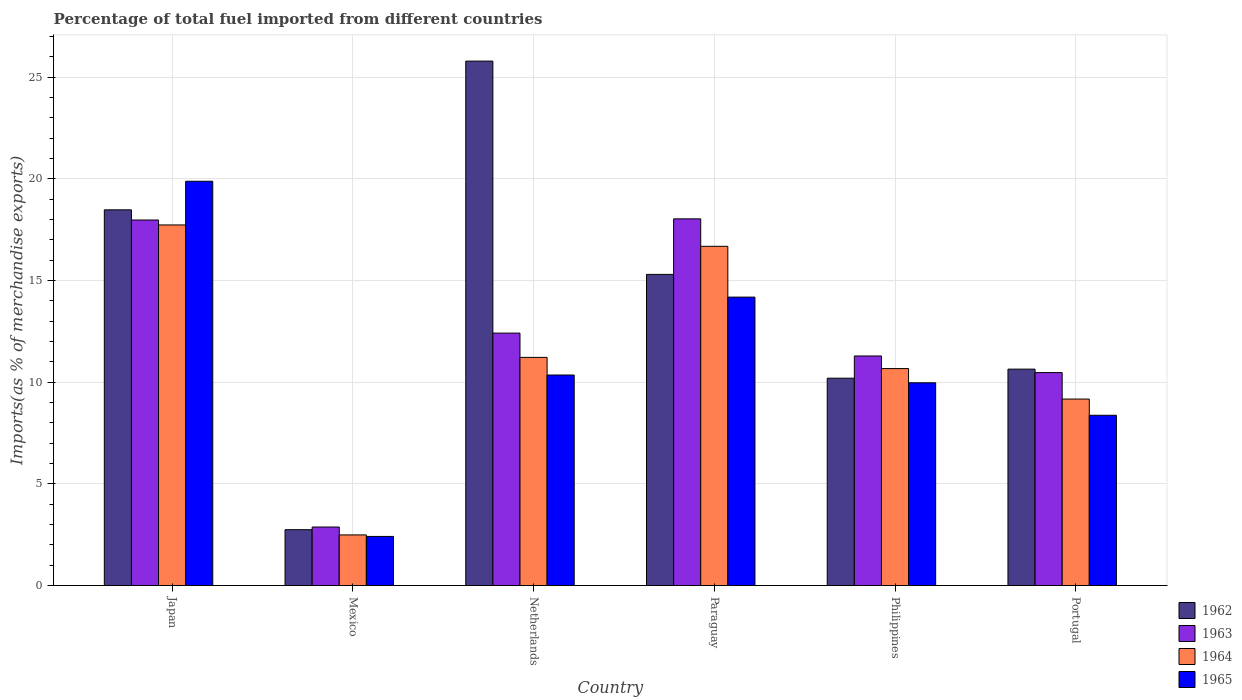How many groups of bars are there?
Your response must be concise. 6. Are the number of bars on each tick of the X-axis equal?
Give a very brief answer. Yes. What is the label of the 4th group of bars from the left?
Your answer should be very brief. Paraguay. In how many cases, is the number of bars for a given country not equal to the number of legend labels?
Provide a short and direct response. 0. What is the percentage of imports to different countries in 1963 in Japan?
Keep it short and to the point. 17.97. Across all countries, what is the maximum percentage of imports to different countries in 1963?
Make the answer very short. 18.03. Across all countries, what is the minimum percentage of imports to different countries in 1962?
Provide a succinct answer. 2.75. In which country was the percentage of imports to different countries in 1962 minimum?
Your response must be concise. Mexico. What is the total percentage of imports to different countries in 1964 in the graph?
Offer a very short reply. 67.96. What is the difference between the percentage of imports to different countries in 1965 in Netherlands and that in Portugal?
Make the answer very short. 1.98. What is the difference between the percentage of imports to different countries in 1963 in Portugal and the percentage of imports to different countries in 1964 in Netherlands?
Offer a very short reply. -0.75. What is the average percentage of imports to different countries in 1963 per country?
Give a very brief answer. 12.18. What is the difference between the percentage of imports to different countries of/in 1962 and percentage of imports to different countries of/in 1964 in Paraguay?
Make the answer very short. -1.38. In how many countries, is the percentage of imports to different countries in 1964 greater than 23 %?
Your answer should be very brief. 0. What is the ratio of the percentage of imports to different countries in 1964 in Japan to that in Portugal?
Give a very brief answer. 1.93. Is the difference between the percentage of imports to different countries in 1962 in Netherlands and Portugal greater than the difference between the percentage of imports to different countries in 1964 in Netherlands and Portugal?
Make the answer very short. Yes. What is the difference between the highest and the second highest percentage of imports to different countries in 1965?
Your answer should be very brief. -9.53. What is the difference between the highest and the lowest percentage of imports to different countries in 1965?
Your response must be concise. 17.46. Is the sum of the percentage of imports to different countries in 1964 in Mexico and Philippines greater than the maximum percentage of imports to different countries in 1963 across all countries?
Offer a very short reply. No. What does the 1st bar from the right in Mexico represents?
Your answer should be very brief. 1965. How many bars are there?
Your answer should be very brief. 24. Are the values on the major ticks of Y-axis written in scientific E-notation?
Provide a succinct answer. No. Where does the legend appear in the graph?
Provide a succinct answer. Bottom right. How many legend labels are there?
Offer a very short reply. 4. What is the title of the graph?
Make the answer very short. Percentage of total fuel imported from different countries. What is the label or title of the X-axis?
Your answer should be very brief. Country. What is the label or title of the Y-axis?
Give a very brief answer. Imports(as % of merchandise exports). What is the Imports(as % of merchandise exports) of 1962 in Japan?
Offer a terse response. 18.47. What is the Imports(as % of merchandise exports) in 1963 in Japan?
Your answer should be compact. 17.97. What is the Imports(as % of merchandise exports) in 1964 in Japan?
Offer a terse response. 17.73. What is the Imports(as % of merchandise exports) in 1965 in Japan?
Your response must be concise. 19.88. What is the Imports(as % of merchandise exports) of 1962 in Mexico?
Your response must be concise. 2.75. What is the Imports(as % of merchandise exports) in 1963 in Mexico?
Ensure brevity in your answer.  2.88. What is the Imports(as % of merchandise exports) in 1964 in Mexico?
Give a very brief answer. 2.49. What is the Imports(as % of merchandise exports) in 1965 in Mexico?
Give a very brief answer. 2.42. What is the Imports(as % of merchandise exports) of 1962 in Netherlands?
Keep it short and to the point. 25.79. What is the Imports(as % of merchandise exports) of 1963 in Netherlands?
Offer a very short reply. 12.41. What is the Imports(as % of merchandise exports) of 1964 in Netherlands?
Your response must be concise. 11.22. What is the Imports(as % of merchandise exports) in 1965 in Netherlands?
Keep it short and to the point. 10.35. What is the Imports(as % of merchandise exports) in 1962 in Paraguay?
Offer a very short reply. 15.3. What is the Imports(as % of merchandise exports) of 1963 in Paraguay?
Offer a very short reply. 18.03. What is the Imports(as % of merchandise exports) in 1964 in Paraguay?
Make the answer very short. 16.68. What is the Imports(as % of merchandise exports) in 1965 in Paraguay?
Provide a short and direct response. 14.18. What is the Imports(as % of merchandise exports) of 1962 in Philippines?
Your answer should be compact. 10.2. What is the Imports(as % of merchandise exports) of 1963 in Philippines?
Your response must be concise. 11.29. What is the Imports(as % of merchandise exports) of 1964 in Philippines?
Provide a succinct answer. 10.67. What is the Imports(as % of merchandise exports) in 1965 in Philippines?
Your answer should be compact. 9.97. What is the Imports(as % of merchandise exports) in 1962 in Portugal?
Make the answer very short. 10.64. What is the Imports(as % of merchandise exports) in 1963 in Portugal?
Ensure brevity in your answer.  10.47. What is the Imports(as % of merchandise exports) of 1964 in Portugal?
Your response must be concise. 9.17. What is the Imports(as % of merchandise exports) in 1965 in Portugal?
Make the answer very short. 8.37. Across all countries, what is the maximum Imports(as % of merchandise exports) in 1962?
Offer a terse response. 25.79. Across all countries, what is the maximum Imports(as % of merchandise exports) of 1963?
Ensure brevity in your answer.  18.03. Across all countries, what is the maximum Imports(as % of merchandise exports) of 1964?
Your answer should be very brief. 17.73. Across all countries, what is the maximum Imports(as % of merchandise exports) in 1965?
Your response must be concise. 19.88. Across all countries, what is the minimum Imports(as % of merchandise exports) of 1962?
Make the answer very short. 2.75. Across all countries, what is the minimum Imports(as % of merchandise exports) in 1963?
Give a very brief answer. 2.88. Across all countries, what is the minimum Imports(as % of merchandise exports) of 1964?
Provide a short and direct response. 2.49. Across all countries, what is the minimum Imports(as % of merchandise exports) in 1965?
Your answer should be compact. 2.42. What is the total Imports(as % of merchandise exports) of 1962 in the graph?
Make the answer very short. 83.15. What is the total Imports(as % of merchandise exports) of 1963 in the graph?
Your response must be concise. 73.06. What is the total Imports(as % of merchandise exports) of 1964 in the graph?
Your answer should be compact. 67.96. What is the total Imports(as % of merchandise exports) in 1965 in the graph?
Provide a succinct answer. 65.17. What is the difference between the Imports(as % of merchandise exports) of 1962 in Japan and that in Mexico?
Provide a succinct answer. 15.73. What is the difference between the Imports(as % of merchandise exports) in 1963 in Japan and that in Mexico?
Give a very brief answer. 15.1. What is the difference between the Imports(as % of merchandise exports) in 1964 in Japan and that in Mexico?
Your answer should be very brief. 15.24. What is the difference between the Imports(as % of merchandise exports) in 1965 in Japan and that in Mexico?
Ensure brevity in your answer.  17.46. What is the difference between the Imports(as % of merchandise exports) of 1962 in Japan and that in Netherlands?
Ensure brevity in your answer.  -7.31. What is the difference between the Imports(as % of merchandise exports) in 1963 in Japan and that in Netherlands?
Provide a short and direct response. 5.56. What is the difference between the Imports(as % of merchandise exports) in 1964 in Japan and that in Netherlands?
Ensure brevity in your answer.  6.51. What is the difference between the Imports(as % of merchandise exports) in 1965 in Japan and that in Netherlands?
Provide a short and direct response. 9.53. What is the difference between the Imports(as % of merchandise exports) in 1962 in Japan and that in Paraguay?
Provide a succinct answer. 3.17. What is the difference between the Imports(as % of merchandise exports) in 1963 in Japan and that in Paraguay?
Keep it short and to the point. -0.06. What is the difference between the Imports(as % of merchandise exports) in 1964 in Japan and that in Paraguay?
Offer a terse response. 1.05. What is the difference between the Imports(as % of merchandise exports) of 1965 in Japan and that in Paraguay?
Your response must be concise. 5.7. What is the difference between the Imports(as % of merchandise exports) in 1962 in Japan and that in Philippines?
Provide a short and direct response. 8.28. What is the difference between the Imports(as % of merchandise exports) of 1963 in Japan and that in Philippines?
Your answer should be compact. 6.69. What is the difference between the Imports(as % of merchandise exports) of 1964 in Japan and that in Philippines?
Keep it short and to the point. 7.06. What is the difference between the Imports(as % of merchandise exports) of 1965 in Japan and that in Philippines?
Provide a short and direct response. 9.91. What is the difference between the Imports(as % of merchandise exports) in 1962 in Japan and that in Portugal?
Provide a succinct answer. 7.83. What is the difference between the Imports(as % of merchandise exports) in 1963 in Japan and that in Portugal?
Provide a short and direct response. 7.5. What is the difference between the Imports(as % of merchandise exports) of 1964 in Japan and that in Portugal?
Make the answer very short. 8.56. What is the difference between the Imports(as % of merchandise exports) in 1965 in Japan and that in Portugal?
Provide a short and direct response. 11.51. What is the difference between the Imports(as % of merchandise exports) of 1962 in Mexico and that in Netherlands?
Provide a short and direct response. -23.04. What is the difference between the Imports(as % of merchandise exports) of 1963 in Mexico and that in Netherlands?
Your answer should be compact. -9.53. What is the difference between the Imports(as % of merchandise exports) in 1964 in Mexico and that in Netherlands?
Offer a very short reply. -8.73. What is the difference between the Imports(as % of merchandise exports) in 1965 in Mexico and that in Netherlands?
Ensure brevity in your answer.  -7.94. What is the difference between the Imports(as % of merchandise exports) of 1962 in Mexico and that in Paraguay?
Offer a terse response. -12.55. What is the difference between the Imports(as % of merchandise exports) of 1963 in Mexico and that in Paraguay?
Provide a succinct answer. -15.15. What is the difference between the Imports(as % of merchandise exports) in 1964 in Mexico and that in Paraguay?
Keep it short and to the point. -14.19. What is the difference between the Imports(as % of merchandise exports) of 1965 in Mexico and that in Paraguay?
Your answer should be compact. -11.77. What is the difference between the Imports(as % of merchandise exports) of 1962 in Mexico and that in Philippines?
Your answer should be very brief. -7.45. What is the difference between the Imports(as % of merchandise exports) in 1963 in Mexico and that in Philippines?
Your answer should be very brief. -8.41. What is the difference between the Imports(as % of merchandise exports) in 1964 in Mexico and that in Philippines?
Offer a terse response. -8.18. What is the difference between the Imports(as % of merchandise exports) of 1965 in Mexico and that in Philippines?
Ensure brevity in your answer.  -7.55. What is the difference between the Imports(as % of merchandise exports) of 1962 in Mexico and that in Portugal?
Provide a short and direct response. -7.89. What is the difference between the Imports(as % of merchandise exports) in 1963 in Mexico and that in Portugal?
Offer a very short reply. -7.59. What is the difference between the Imports(as % of merchandise exports) of 1964 in Mexico and that in Portugal?
Ensure brevity in your answer.  -6.68. What is the difference between the Imports(as % of merchandise exports) in 1965 in Mexico and that in Portugal?
Provide a short and direct response. -5.96. What is the difference between the Imports(as % of merchandise exports) in 1962 in Netherlands and that in Paraguay?
Your response must be concise. 10.49. What is the difference between the Imports(as % of merchandise exports) in 1963 in Netherlands and that in Paraguay?
Your answer should be very brief. -5.62. What is the difference between the Imports(as % of merchandise exports) in 1964 in Netherlands and that in Paraguay?
Give a very brief answer. -5.46. What is the difference between the Imports(as % of merchandise exports) in 1965 in Netherlands and that in Paraguay?
Keep it short and to the point. -3.83. What is the difference between the Imports(as % of merchandise exports) in 1962 in Netherlands and that in Philippines?
Your response must be concise. 15.59. What is the difference between the Imports(as % of merchandise exports) of 1963 in Netherlands and that in Philippines?
Ensure brevity in your answer.  1.12. What is the difference between the Imports(as % of merchandise exports) of 1964 in Netherlands and that in Philippines?
Give a very brief answer. 0.55. What is the difference between the Imports(as % of merchandise exports) of 1965 in Netherlands and that in Philippines?
Offer a very short reply. 0.38. What is the difference between the Imports(as % of merchandise exports) of 1962 in Netherlands and that in Portugal?
Keep it short and to the point. 15.15. What is the difference between the Imports(as % of merchandise exports) in 1963 in Netherlands and that in Portugal?
Your answer should be very brief. 1.94. What is the difference between the Imports(as % of merchandise exports) of 1964 in Netherlands and that in Portugal?
Ensure brevity in your answer.  2.05. What is the difference between the Imports(as % of merchandise exports) in 1965 in Netherlands and that in Portugal?
Provide a short and direct response. 1.98. What is the difference between the Imports(as % of merchandise exports) in 1962 in Paraguay and that in Philippines?
Your answer should be compact. 5.1. What is the difference between the Imports(as % of merchandise exports) in 1963 in Paraguay and that in Philippines?
Your response must be concise. 6.74. What is the difference between the Imports(as % of merchandise exports) in 1964 in Paraguay and that in Philippines?
Keep it short and to the point. 6.01. What is the difference between the Imports(as % of merchandise exports) in 1965 in Paraguay and that in Philippines?
Your answer should be compact. 4.21. What is the difference between the Imports(as % of merchandise exports) in 1962 in Paraguay and that in Portugal?
Ensure brevity in your answer.  4.66. What is the difference between the Imports(as % of merchandise exports) in 1963 in Paraguay and that in Portugal?
Give a very brief answer. 7.56. What is the difference between the Imports(as % of merchandise exports) in 1964 in Paraguay and that in Portugal?
Keep it short and to the point. 7.51. What is the difference between the Imports(as % of merchandise exports) in 1965 in Paraguay and that in Portugal?
Offer a terse response. 5.81. What is the difference between the Imports(as % of merchandise exports) of 1962 in Philippines and that in Portugal?
Offer a very short reply. -0.45. What is the difference between the Imports(as % of merchandise exports) in 1963 in Philippines and that in Portugal?
Your response must be concise. 0.82. What is the difference between the Imports(as % of merchandise exports) of 1964 in Philippines and that in Portugal?
Provide a short and direct response. 1.5. What is the difference between the Imports(as % of merchandise exports) of 1965 in Philippines and that in Portugal?
Offer a very short reply. 1.6. What is the difference between the Imports(as % of merchandise exports) in 1962 in Japan and the Imports(as % of merchandise exports) in 1963 in Mexico?
Your answer should be very brief. 15.6. What is the difference between the Imports(as % of merchandise exports) in 1962 in Japan and the Imports(as % of merchandise exports) in 1964 in Mexico?
Your response must be concise. 15.98. What is the difference between the Imports(as % of merchandise exports) of 1962 in Japan and the Imports(as % of merchandise exports) of 1965 in Mexico?
Keep it short and to the point. 16.06. What is the difference between the Imports(as % of merchandise exports) in 1963 in Japan and the Imports(as % of merchandise exports) in 1964 in Mexico?
Offer a terse response. 15.48. What is the difference between the Imports(as % of merchandise exports) in 1963 in Japan and the Imports(as % of merchandise exports) in 1965 in Mexico?
Provide a short and direct response. 15.56. What is the difference between the Imports(as % of merchandise exports) of 1964 in Japan and the Imports(as % of merchandise exports) of 1965 in Mexico?
Provide a succinct answer. 15.32. What is the difference between the Imports(as % of merchandise exports) in 1962 in Japan and the Imports(as % of merchandise exports) in 1963 in Netherlands?
Keep it short and to the point. 6.06. What is the difference between the Imports(as % of merchandise exports) of 1962 in Japan and the Imports(as % of merchandise exports) of 1964 in Netherlands?
Your answer should be very brief. 7.25. What is the difference between the Imports(as % of merchandise exports) of 1962 in Japan and the Imports(as % of merchandise exports) of 1965 in Netherlands?
Give a very brief answer. 8.12. What is the difference between the Imports(as % of merchandise exports) of 1963 in Japan and the Imports(as % of merchandise exports) of 1964 in Netherlands?
Provide a short and direct response. 6.76. What is the difference between the Imports(as % of merchandise exports) in 1963 in Japan and the Imports(as % of merchandise exports) in 1965 in Netherlands?
Provide a short and direct response. 7.62. What is the difference between the Imports(as % of merchandise exports) of 1964 in Japan and the Imports(as % of merchandise exports) of 1965 in Netherlands?
Offer a very short reply. 7.38. What is the difference between the Imports(as % of merchandise exports) of 1962 in Japan and the Imports(as % of merchandise exports) of 1963 in Paraguay?
Offer a terse response. 0.44. What is the difference between the Imports(as % of merchandise exports) in 1962 in Japan and the Imports(as % of merchandise exports) in 1964 in Paraguay?
Keep it short and to the point. 1.79. What is the difference between the Imports(as % of merchandise exports) of 1962 in Japan and the Imports(as % of merchandise exports) of 1965 in Paraguay?
Provide a short and direct response. 4.29. What is the difference between the Imports(as % of merchandise exports) in 1963 in Japan and the Imports(as % of merchandise exports) in 1964 in Paraguay?
Make the answer very short. 1.29. What is the difference between the Imports(as % of merchandise exports) in 1963 in Japan and the Imports(as % of merchandise exports) in 1965 in Paraguay?
Give a very brief answer. 3.79. What is the difference between the Imports(as % of merchandise exports) in 1964 in Japan and the Imports(as % of merchandise exports) in 1965 in Paraguay?
Offer a terse response. 3.55. What is the difference between the Imports(as % of merchandise exports) in 1962 in Japan and the Imports(as % of merchandise exports) in 1963 in Philippines?
Your response must be concise. 7.19. What is the difference between the Imports(as % of merchandise exports) of 1962 in Japan and the Imports(as % of merchandise exports) of 1964 in Philippines?
Give a very brief answer. 7.81. What is the difference between the Imports(as % of merchandise exports) of 1962 in Japan and the Imports(as % of merchandise exports) of 1965 in Philippines?
Your response must be concise. 8.5. What is the difference between the Imports(as % of merchandise exports) of 1963 in Japan and the Imports(as % of merchandise exports) of 1964 in Philippines?
Offer a very short reply. 7.31. What is the difference between the Imports(as % of merchandise exports) in 1963 in Japan and the Imports(as % of merchandise exports) in 1965 in Philippines?
Your answer should be very brief. 8. What is the difference between the Imports(as % of merchandise exports) of 1964 in Japan and the Imports(as % of merchandise exports) of 1965 in Philippines?
Your answer should be compact. 7.76. What is the difference between the Imports(as % of merchandise exports) in 1962 in Japan and the Imports(as % of merchandise exports) in 1963 in Portugal?
Ensure brevity in your answer.  8. What is the difference between the Imports(as % of merchandise exports) in 1962 in Japan and the Imports(as % of merchandise exports) in 1964 in Portugal?
Offer a very short reply. 9.3. What is the difference between the Imports(as % of merchandise exports) in 1962 in Japan and the Imports(as % of merchandise exports) in 1965 in Portugal?
Make the answer very short. 10.1. What is the difference between the Imports(as % of merchandise exports) of 1963 in Japan and the Imports(as % of merchandise exports) of 1964 in Portugal?
Your response must be concise. 8.8. What is the difference between the Imports(as % of merchandise exports) in 1963 in Japan and the Imports(as % of merchandise exports) in 1965 in Portugal?
Offer a terse response. 9.6. What is the difference between the Imports(as % of merchandise exports) of 1964 in Japan and the Imports(as % of merchandise exports) of 1965 in Portugal?
Offer a terse response. 9.36. What is the difference between the Imports(as % of merchandise exports) of 1962 in Mexico and the Imports(as % of merchandise exports) of 1963 in Netherlands?
Your answer should be very brief. -9.67. What is the difference between the Imports(as % of merchandise exports) of 1962 in Mexico and the Imports(as % of merchandise exports) of 1964 in Netherlands?
Ensure brevity in your answer.  -8.47. What is the difference between the Imports(as % of merchandise exports) of 1962 in Mexico and the Imports(as % of merchandise exports) of 1965 in Netherlands?
Provide a succinct answer. -7.61. What is the difference between the Imports(as % of merchandise exports) in 1963 in Mexico and the Imports(as % of merchandise exports) in 1964 in Netherlands?
Offer a terse response. -8.34. What is the difference between the Imports(as % of merchandise exports) of 1963 in Mexico and the Imports(as % of merchandise exports) of 1965 in Netherlands?
Your response must be concise. -7.47. What is the difference between the Imports(as % of merchandise exports) of 1964 in Mexico and the Imports(as % of merchandise exports) of 1965 in Netherlands?
Your answer should be very brief. -7.86. What is the difference between the Imports(as % of merchandise exports) in 1962 in Mexico and the Imports(as % of merchandise exports) in 1963 in Paraguay?
Make the answer very short. -15.28. What is the difference between the Imports(as % of merchandise exports) of 1962 in Mexico and the Imports(as % of merchandise exports) of 1964 in Paraguay?
Ensure brevity in your answer.  -13.93. What is the difference between the Imports(as % of merchandise exports) of 1962 in Mexico and the Imports(as % of merchandise exports) of 1965 in Paraguay?
Ensure brevity in your answer.  -11.44. What is the difference between the Imports(as % of merchandise exports) in 1963 in Mexico and the Imports(as % of merchandise exports) in 1964 in Paraguay?
Provide a short and direct response. -13.8. What is the difference between the Imports(as % of merchandise exports) of 1963 in Mexico and the Imports(as % of merchandise exports) of 1965 in Paraguay?
Offer a very short reply. -11.3. What is the difference between the Imports(as % of merchandise exports) of 1964 in Mexico and the Imports(as % of merchandise exports) of 1965 in Paraguay?
Provide a succinct answer. -11.69. What is the difference between the Imports(as % of merchandise exports) of 1962 in Mexico and the Imports(as % of merchandise exports) of 1963 in Philippines?
Provide a succinct answer. -8.54. What is the difference between the Imports(as % of merchandise exports) in 1962 in Mexico and the Imports(as % of merchandise exports) in 1964 in Philippines?
Your response must be concise. -7.92. What is the difference between the Imports(as % of merchandise exports) of 1962 in Mexico and the Imports(as % of merchandise exports) of 1965 in Philippines?
Keep it short and to the point. -7.22. What is the difference between the Imports(as % of merchandise exports) in 1963 in Mexico and the Imports(as % of merchandise exports) in 1964 in Philippines?
Provide a succinct answer. -7.79. What is the difference between the Imports(as % of merchandise exports) in 1963 in Mexico and the Imports(as % of merchandise exports) in 1965 in Philippines?
Make the answer very short. -7.09. What is the difference between the Imports(as % of merchandise exports) in 1964 in Mexico and the Imports(as % of merchandise exports) in 1965 in Philippines?
Offer a very short reply. -7.48. What is the difference between the Imports(as % of merchandise exports) in 1962 in Mexico and the Imports(as % of merchandise exports) in 1963 in Portugal?
Offer a very short reply. -7.73. What is the difference between the Imports(as % of merchandise exports) of 1962 in Mexico and the Imports(as % of merchandise exports) of 1964 in Portugal?
Give a very brief answer. -6.42. What is the difference between the Imports(as % of merchandise exports) in 1962 in Mexico and the Imports(as % of merchandise exports) in 1965 in Portugal?
Provide a short and direct response. -5.63. What is the difference between the Imports(as % of merchandise exports) of 1963 in Mexico and the Imports(as % of merchandise exports) of 1964 in Portugal?
Your response must be concise. -6.29. What is the difference between the Imports(as % of merchandise exports) of 1963 in Mexico and the Imports(as % of merchandise exports) of 1965 in Portugal?
Your response must be concise. -5.49. What is the difference between the Imports(as % of merchandise exports) of 1964 in Mexico and the Imports(as % of merchandise exports) of 1965 in Portugal?
Your answer should be very brief. -5.88. What is the difference between the Imports(as % of merchandise exports) in 1962 in Netherlands and the Imports(as % of merchandise exports) in 1963 in Paraguay?
Your answer should be very brief. 7.76. What is the difference between the Imports(as % of merchandise exports) of 1962 in Netherlands and the Imports(as % of merchandise exports) of 1964 in Paraguay?
Give a very brief answer. 9.11. What is the difference between the Imports(as % of merchandise exports) of 1962 in Netherlands and the Imports(as % of merchandise exports) of 1965 in Paraguay?
Offer a very short reply. 11.6. What is the difference between the Imports(as % of merchandise exports) of 1963 in Netherlands and the Imports(as % of merchandise exports) of 1964 in Paraguay?
Keep it short and to the point. -4.27. What is the difference between the Imports(as % of merchandise exports) in 1963 in Netherlands and the Imports(as % of merchandise exports) in 1965 in Paraguay?
Your answer should be compact. -1.77. What is the difference between the Imports(as % of merchandise exports) in 1964 in Netherlands and the Imports(as % of merchandise exports) in 1965 in Paraguay?
Ensure brevity in your answer.  -2.96. What is the difference between the Imports(as % of merchandise exports) of 1962 in Netherlands and the Imports(as % of merchandise exports) of 1963 in Philippines?
Provide a succinct answer. 14.5. What is the difference between the Imports(as % of merchandise exports) of 1962 in Netherlands and the Imports(as % of merchandise exports) of 1964 in Philippines?
Keep it short and to the point. 15.12. What is the difference between the Imports(as % of merchandise exports) of 1962 in Netherlands and the Imports(as % of merchandise exports) of 1965 in Philippines?
Offer a terse response. 15.82. What is the difference between the Imports(as % of merchandise exports) of 1963 in Netherlands and the Imports(as % of merchandise exports) of 1964 in Philippines?
Keep it short and to the point. 1.74. What is the difference between the Imports(as % of merchandise exports) in 1963 in Netherlands and the Imports(as % of merchandise exports) in 1965 in Philippines?
Offer a terse response. 2.44. What is the difference between the Imports(as % of merchandise exports) in 1964 in Netherlands and the Imports(as % of merchandise exports) in 1965 in Philippines?
Ensure brevity in your answer.  1.25. What is the difference between the Imports(as % of merchandise exports) of 1962 in Netherlands and the Imports(as % of merchandise exports) of 1963 in Portugal?
Ensure brevity in your answer.  15.32. What is the difference between the Imports(as % of merchandise exports) in 1962 in Netherlands and the Imports(as % of merchandise exports) in 1964 in Portugal?
Your answer should be very brief. 16.62. What is the difference between the Imports(as % of merchandise exports) of 1962 in Netherlands and the Imports(as % of merchandise exports) of 1965 in Portugal?
Ensure brevity in your answer.  17.41. What is the difference between the Imports(as % of merchandise exports) in 1963 in Netherlands and the Imports(as % of merchandise exports) in 1964 in Portugal?
Your answer should be compact. 3.24. What is the difference between the Imports(as % of merchandise exports) in 1963 in Netherlands and the Imports(as % of merchandise exports) in 1965 in Portugal?
Keep it short and to the point. 4.04. What is the difference between the Imports(as % of merchandise exports) in 1964 in Netherlands and the Imports(as % of merchandise exports) in 1965 in Portugal?
Make the answer very short. 2.85. What is the difference between the Imports(as % of merchandise exports) of 1962 in Paraguay and the Imports(as % of merchandise exports) of 1963 in Philippines?
Provide a succinct answer. 4.01. What is the difference between the Imports(as % of merchandise exports) of 1962 in Paraguay and the Imports(as % of merchandise exports) of 1964 in Philippines?
Ensure brevity in your answer.  4.63. What is the difference between the Imports(as % of merchandise exports) in 1962 in Paraguay and the Imports(as % of merchandise exports) in 1965 in Philippines?
Your answer should be compact. 5.33. What is the difference between the Imports(as % of merchandise exports) in 1963 in Paraguay and the Imports(as % of merchandise exports) in 1964 in Philippines?
Ensure brevity in your answer.  7.36. What is the difference between the Imports(as % of merchandise exports) in 1963 in Paraguay and the Imports(as % of merchandise exports) in 1965 in Philippines?
Your answer should be very brief. 8.06. What is the difference between the Imports(as % of merchandise exports) in 1964 in Paraguay and the Imports(as % of merchandise exports) in 1965 in Philippines?
Your answer should be compact. 6.71. What is the difference between the Imports(as % of merchandise exports) in 1962 in Paraguay and the Imports(as % of merchandise exports) in 1963 in Portugal?
Your response must be concise. 4.83. What is the difference between the Imports(as % of merchandise exports) in 1962 in Paraguay and the Imports(as % of merchandise exports) in 1964 in Portugal?
Provide a succinct answer. 6.13. What is the difference between the Imports(as % of merchandise exports) in 1962 in Paraguay and the Imports(as % of merchandise exports) in 1965 in Portugal?
Make the answer very short. 6.93. What is the difference between the Imports(as % of merchandise exports) in 1963 in Paraguay and the Imports(as % of merchandise exports) in 1964 in Portugal?
Offer a terse response. 8.86. What is the difference between the Imports(as % of merchandise exports) in 1963 in Paraguay and the Imports(as % of merchandise exports) in 1965 in Portugal?
Offer a terse response. 9.66. What is the difference between the Imports(as % of merchandise exports) of 1964 in Paraguay and the Imports(as % of merchandise exports) of 1965 in Portugal?
Offer a terse response. 8.31. What is the difference between the Imports(as % of merchandise exports) of 1962 in Philippines and the Imports(as % of merchandise exports) of 1963 in Portugal?
Offer a terse response. -0.28. What is the difference between the Imports(as % of merchandise exports) of 1962 in Philippines and the Imports(as % of merchandise exports) of 1964 in Portugal?
Provide a short and direct response. 1.03. What is the difference between the Imports(as % of merchandise exports) of 1962 in Philippines and the Imports(as % of merchandise exports) of 1965 in Portugal?
Your answer should be very brief. 1.82. What is the difference between the Imports(as % of merchandise exports) of 1963 in Philippines and the Imports(as % of merchandise exports) of 1964 in Portugal?
Give a very brief answer. 2.12. What is the difference between the Imports(as % of merchandise exports) in 1963 in Philippines and the Imports(as % of merchandise exports) in 1965 in Portugal?
Provide a short and direct response. 2.92. What is the difference between the Imports(as % of merchandise exports) in 1964 in Philippines and the Imports(as % of merchandise exports) in 1965 in Portugal?
Your answer should be very brief. 2.3. What is the average Imports(as % of merchandise exports) of 1962 per country?
Provide a succinct answer. 13.86. What is the average Imports(as % of merchandise exports) of 1963 per country?
Provide a short and direct response. 12.18. What is the average Imports(as % of merchandise exports) of 1964 per country?
Provide a succinct answer. 11.33. What is the average Imports(as % of merchandise exports) in 1965 per country?
Provide a succinct answer. 10.86. What is the difference between the Imports(as % of merchandise exports) of 1962 and Imports(as % of merchandise exports) of 1964 in Japan?
Your response must be concise. 0.74. What is the difference between the Imports(as % of merchandise exports) of 1962 and Imports(as % of merchandise exports) of 1965 in Japan?
Give a very brief answer. -1.41. What is the difference between the Imports(as % of merchandise exports) of 1963 and Imports(as % of merchandise exports) of 1964 in Japan?
Keep it short and to the point. 0.24. What is the difference between the Imports(as % of merchandise exports) in 1963 and Imports(as % of merchandise exports) in 1965 in Japan?
Give a very brief answer. -1.91. What is the difference between the Imports(as % of merchandise exports) of 1964 and Imports(as % of merchandise exports) of 1965 in Japan?
Your response must be concise. -2.15. What is the difference between the Imports(as % of merchandise exports) in 1962 and Imports(as % of merchandise exports) in 1963 in Mexico?
Give a very brief answer. -0.13. What is the difference between the Imports(as % of merchandise exports) of 1962 and Imports(as % of merchandise exports) of 1964 in Mexico?
Provide a short and direct response. 0.26. What is the difference between the Imports(as % of merchandise exports) of 1962 and Imports(as % of merchandise exports) of 1965 in Mexico?
Offer a terse response. 0.33. What is the difference between the Imports(as % of merchandise exports) in 1963 and Imports(as % of merchandise exports) in 1964 in Mexico?
Make the answer very short. 0.39. What is the difference between the Imports(as % of merchandise exports) of 1963 and Imports(as % of merchandise exports) of 1965 in Mexico?
Keep it short and to the point. 0.46. What is the difference between the Imports(as % of merchandise exports) in 1964 and Imports(as % of merchandise exports) in 1965 in Mexico?
Give a very brief answer. 0.07. What is the difference between the Imports(as % of merchandise exports) in 1962 and Imports(as % of merchandise exports) in 1963 in Netherlands?
Keep it short and to the point. 13.37. What is the difference between the Imports(as % of merchandise exports) of 1962 and Imports(as % of merchandise exports) of 1964 in Netherlands?
Make the answer very short. 14.57. What is the difference between the Imports(as % of merchandise exports) in 1962 and Imports(as % of merchandise exports) in 1965 in Netherlands?
Provide a succinct answer. 15.43. What is the difference between the Imports(as % of merchandise exports) of 1963 and Imports(as % of merchandise exports) of 1964 in Netherlands?
Offer a terse response. 1.19. What is the difference between the Imports(as % of merchandise exports) of 1963 and Imports(as % of merchandise exports) of 1965 in Netherlands?
Provide a short and direct response. 2.06. What is the difference between the Imports(as % of merchandise exports) in 1964 and Imports(as % of merchandise exports) in 1965 in Netherlands?
Offer a terse response. 0.87. What is the difference between the Imports(as % of merchandise exports) in 1962 and Imports(as % of merchandise exports) in 1963 in Paraguay?
Offer a very short reply. -2.73. What is the difference between the Imports(as % of merchandise exports) of 1962 and Imports(as % of merchandise exports) of 1964 in Paraguay?
Keep it short and to the point. -1.38. What is the difference between the Imports(as % of merchandise exports) of 1962 and Imports(as % of merchandise exports) of 1965 in Paraguay?
Make the answer very short. 1.12. What is the difference between the Imports(as % of merchandise exports) of 1963 and Imports(as % of merchandise exports) of 1964 in Paraguay?
Provide a succinct answer. 1.35. What is the difference between the Imports(as % of merchandise exports) of 1963 and Imports(as % of merchandise exports) of 1965 in Paraguay?
Provide a succinct answer. 3.85. What is the difference between the Imports(as % of merchandise exports) in 1964 and Imports(as % of merchandise exports) in 1965 in Paraguay?
Keep it short and to the point. 2.5. What is the difference between the Imports(as % of merchandise exports) of 1962 and Imports(as % of merchandise exports) of 1963 in Philippines?
Keep it short and to the point. -1.09. What is the difference between the Imports(as % of merchandise exports) in 1962 and Imports(as % of merchandise exports) in 1964 in Philippines?
Give a very brief answer. -0.47. What is the difference between the Imports(as % of merchandise exports) of 1962 and Imports(as % of merchandise exports) of 1965 in Philippines?
Provide a short and direct response. 0.23. What is the difference between the Imports(as % of merchandise exports) of 1963 and Imports(as % of merchandise exports) of 1964 in Philippines?
Your answer should be very brief. 0.62. What is the difference between the Imports(as % of merchandise exports) of 1963 and Imports(as % of merchandise exports) of 1965 in Philippines?
Offer a terse response. 1.32. What is the difference between the Imports(as % of merchandise exports) of 1964 and Imports(as % of merchandise exports) of 1965 in Philippines?
Your answer should be very brief. 0.7. What is the difference between the Imports(as % of merchandise exports) of 1962 and Imports(as % of merchandise exports) of 1963 in Portugal?
Give a very brief answer. 0.17. What is the difference between the Imports(as % of merchandise exports) in 1962 and Imports(as % of merchandise exports) in 1964 in Portugal?
Ensure brevity in your answer.  1.47. What is the difference between the Imports(as % of merchandise exports) in 1962 and Imports(as % of merchandise exports) in 1965 in Portugal?
Provide a short and direct response. 2.27. What is the difference between the Imports(as % of merchandise exports) in 1963 and Imports(as % of merchandise exports) in 1964 in Portugal?
Provide a succinct answer. 1.3. What is the difference between the Imports(as % of merchandise exports) in 1963 and Imports(as % of merchandise exports) in 1965 in Portugal?
Make the answer very short. 2.1. What is the difference between the Imports(as % of merchandise exports) in 1964 and Imports(as % of merchandise exports) in 1965 in Portugal?
Provide a succinct answer. 0.8. What is the ratio of the Imports(as % of merchandise exports) in 1962 in Japan to that in Mexico?
Offer a terse response. 6.72. What is the ratio of the Imports(as % of merchandise exports) of 1963 in Japan to that in Mexico?
Your response must be concise. 6.24. What is the ratio of the Imports(as % of merchandise exports) of 1964 in Japan to that in Mexico?
Your answer should be very brief. 7.12. What is the ratio of the Imports(as % of merchandise exports) in 1965 in Japan to that in Mexico?
Provide a short and direct response. 8.23. What is the ratio of the Imports(as % of merchandise exports) in 1962 in Japan to that in Netherlands?
Your answer should be very brief. 0.72. What is the ratio of the Imports(as % of merchandise exports) in 1963 in Japan to that in Netherlands?
Provide a short and direct response. 1.45. What is the ratio of the Imports(as % of merchandise exports) of 1964 in Japan to that in Netherlands?
Keep it short and to the point. 1.58. What is the ratio of the Imports(as % of merchandise exports) in 1965 in Japan to that in Netherlands?
Ensure brevity in your answer.  1.92. What is the ratio of the Imports(as % of merchandise exports) in 1962 in Japan to that in Paraguay?
Keep it short and to the point. 1.21. What is the ratio of the Imports(as % of merchandise exports) in 1964 in Japan to that in Paraguay?
Offer a terse response. 1.06. What is the ratio of the Imports(as % of merchandise exports) in 1965 in Japan to that in Paraguay?
Offer a very short reply. 1.4. What is the ratio of the Imports(as % of merchandise exports) in 1962 in Japan to that in Philippines?
Offer a terse response. 1.81. What is the ratio of the Imports(as % of merchandise exports) of 1963 in Japan to that in Philippines?
Offer a very short reply. 1.59. What is the ratio of the Imports(as % of merchandise exports) of 1964 in Japan to that in Philippines?
Keep it short and to the point. 1.66. What is the ratio of the Imports(as % of merchandise exports) of 1965 in Japan to that in Philippines?
Offer a very short reply. 1.99. What is the ratio of the Imports(as % of merchandise exports) in 1962 in Japan to that in Portugal?
Provide a short and direct response. 1.74. What is the ratio of the Imports(as % of merchandise exports) in 1963 in Japan to that in Portugal?
Your answer should be compact. 1.72. What is the ratio of the Imports(as % of merchandise exports) in 1964 in Japan to that in Portugal?
Your answer should be very brief. 1.93. What is the ratio of the Imports(as % of merchandise exports) of 1965 in Japan to that in Portugal?
Your answer should be compact. 2.37. What is the ratio of the Imports(as % of merchandise exports) in 1962 in Mexico to that in Netherlands?
Provide a succinct answer. 0.11. What is the ratio of the Imports(as % of merchandise exports) of 1963 in Mexico to that in Netherlands?
Your response must be concise. 0.23. What is the ratio of the Imports(as % of merchandise exports) of 1964 in Mexico to that in Netherlands?
Keep it short and to the point. 0.22. What is the ratio of the Imports(as % of merchandise exports) of 1965 in Mexico to that in Netherlands?
Provide a short and direct response. 0.23. What is the ratio of the Imports(as % of merchandise exports) in 1962 in Mexico to that in Paraguay?
Keep it short and to the point. 0.18. What is the ratio of the Imports(as % of merchandise exports) in 1963 in Mexico to that in Paraguay?
Your answer should be compact. 0.16. What is the ratio of the Imports(as % of merchandise exports) of 1964 in Mexico to that in Paraguay?
Provide a short and direct response. 0.15. What is the ratio of the Imports(as % of merchandise exports) in 1965 in Mexico to that in Paraguay?
Offer a terse response. 0.17. What is the ratio of the Imports(as % of merchandise exports) of 1962 in Mexico to that in Philippines?
Provide a short and direct response. 0.27. What is the ratio of the Imports(as % of merchandise exports) of 1963 in Mexico to that in Philippines?
Your response must be concise. 0.26. What is the ratio of the Imports(as % of merchandise exports) in 1964 in Mexico to that in Philippines?
Keep it short and to the point. 0.23. What is the ratio of the Imports(as % of merchandise exports) in 1965 in Mexico to that in Philippines?
Make the answer very short. 0.24. What is the ratio of the Imports(as % of merchandise exports) in 1962 in Mexico to that in Portugal?
Provide a short and direct response. 0.26. What is the ratio of the Imports(as % of merchandise exports) of 1963 in Mexico to that in Portugal?
Offer a very short reply. 0.27. What is the ratio of the Imports(as % of merchandise exports) in 1964 in Mexico to that in Portugal?
Ensure brevity in your answer.  0.27. What is the ratio of the Imports(as % of merchandise exports) in 1965 in Mexico to that in Portugal?
Offer a terse response. 0.29. What is the ratio of the Imports(as % of merchandise exports) of 1962 in Netherlands to that in Paraguay?
Provide a succinct answer. 1.69. What is the ratio of the Imports(as % of merchandise exports) of 1963 in Netherlands to that in Paraguay?
Offer a terse response. 0.69. What is the ratio of the Imports(as % of merchandise exports) in 1964 in Netherlands to that in Paraguay?
Your response must be concise. 0.67. What is the ratio of the Imports(as % of merchandise exports) in 1965 in Netherlands to that in Paraguay?
Your answer should be very brief. 0.73. What is the ratio of the Imports(as % of merchandise exports) of 1962 in Netherlands to that in Philippines?
Your response must be concise. 2.53. What is the ratio of the Imports(as % of merchandise exports) of 1963 in Netherlands to that in Philippines?
Give a very brief answer. 1.1. What is the ratio of the Imports(as % of merchandise exports) of 1964 in Netherlands to that in Philippines?
Your answer should be compact. 1.05. What is the ratio of the Imports(as % of merchandise exports) of 1965 in Netherlands to that in Philippines?
Make the answer very short. 1.04. What is the ratio of the Imports(as % of merchandise exports) in 1962 in Netherlands to that in Portugal?
Make the answer very short. 2.42. What is the ratio of the Imports(as % of merchandise exports) of 1963 in Netherlands to that in Portugal?
Provide a short and direct response. 1.19. What is the ratio of the Imports(as % of merchandise exports) in 1964 in Netherlands to that in Portugal?
Your answer should be very brief. 1.22. What is the ratio of the Imports(as % of merchandise exports) of 1965 in Netherlands to that in Portugal?
Your answer should be very brief. 1.24. What is the ratio of the Imports(as % of merchandise exports) of 1962 in Paraguay to that in Philippines?
Your response must be concise. 1.5. What is the ratio of the Imports(as % of merchandise exports) in 1963 in Paraguay to that in Philippines?
Your answer should be very brief. 1.6. What is the ratio of the Imports(as % of merchandise exports) of 1964 in Paraguay to that in Philippines?
Keep it short and to the point. 1.56. What is the ratio of the Imports(as % of merchandise exports) of 1965 in Paraguay to that in Philippines?
Ensure brevity in your answer.  1.42. What is the ratio of the Imports(as % of merchandise exports) in 1962 in Paraguay to that in Portugal?
Your response must be concise. 1.44. What is the ratio of the Imports(as % of merchandise exports) in 1963 in Paraguay to that in Portugal?
Your answer should be compact. 1.72. What is the ratio of the Imports(as % of merchandise exports) of 1964 in Paraguay to that in Portugal?
Your response must be concise. 1.82. What is the ratio of the Imports(as % of merchandise exports) of 1965 in Paraguay to that in Portugal?
Provide a succinct answer. 1.69. What is the ratio of the Imports(as % of merchandise exports) of 1962 in Philippines to that in Portugal?
Your response must be concise. 0.96. What is the ratio of the Imports(as % of merchandise exports) of 1963 in Philippines to that in Portugal?
Provide a succinct answer. 1.08. What is the ratio of the Imports(as % of merchandise exports) of 1964 in Philippines to that in Portugal?
Offer a terse response. 1.16. What is the ratio of the Imports(as % of merchandise exports) of 1965 in Philippines to that in Portugal?
Offer a very short reply. 1.19. What is the difference between the highest and the second highest Imports(as % of merchandise exports) of 1962?
Make the answer very short. 7.31. What is the difference between the highest and the second highest Imports(as % of merchandise exports) of 1963?
Make the answer very short. 0.06. What is the difference between the highest and the second highest Imports(as % of merchandise exports) in 1964?
Your response must be concise. 1.05. What is the difference between the highest and the second highest Imports(as % of merchandise exports) in 1965?
Offer a terse response. 5.7. What is the difference between the highest and the lowest Imports(as % of merchandise exports) of 1962?
Keep it short and to the point. 23.04. What is the difference between the highest and the lowest Imports(as % of merchandise exports) in 1963?
Keep it short and to the point. 15.15. What is the difference between the highest and the lowest Imports(as % of merchandise exports) in 1964?
Give a very brief answer. 15.24. What is the difference between the highest and the lowest Imports(as % of merchandise exports) of 1965?
Offer a terse response. 17.46. 